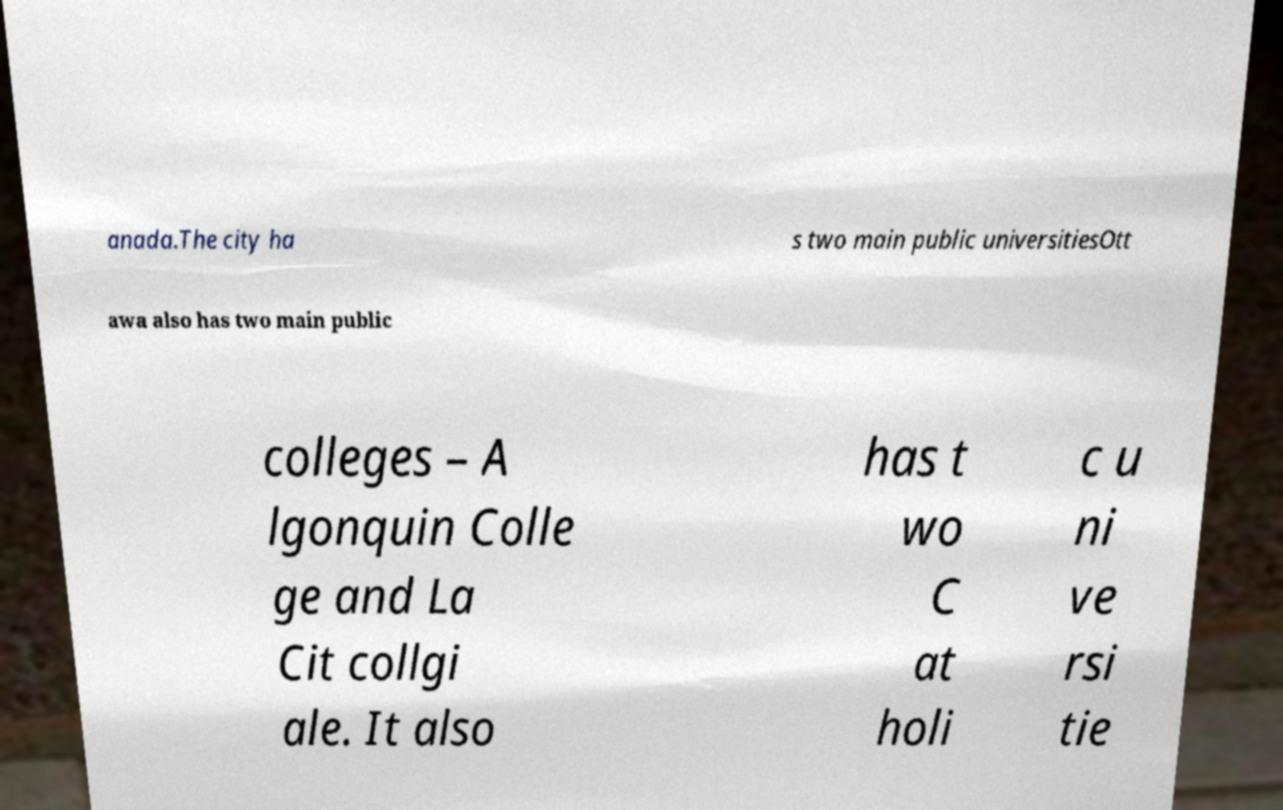Please identify and transcribe the text found in this image. anada.The city ha s two main public universitiesOtt awa also has two main public colleges – A lgonquin Colle ge and La Cit collgi ale. It also has t wo C at holi c u ni ve rsi tie 